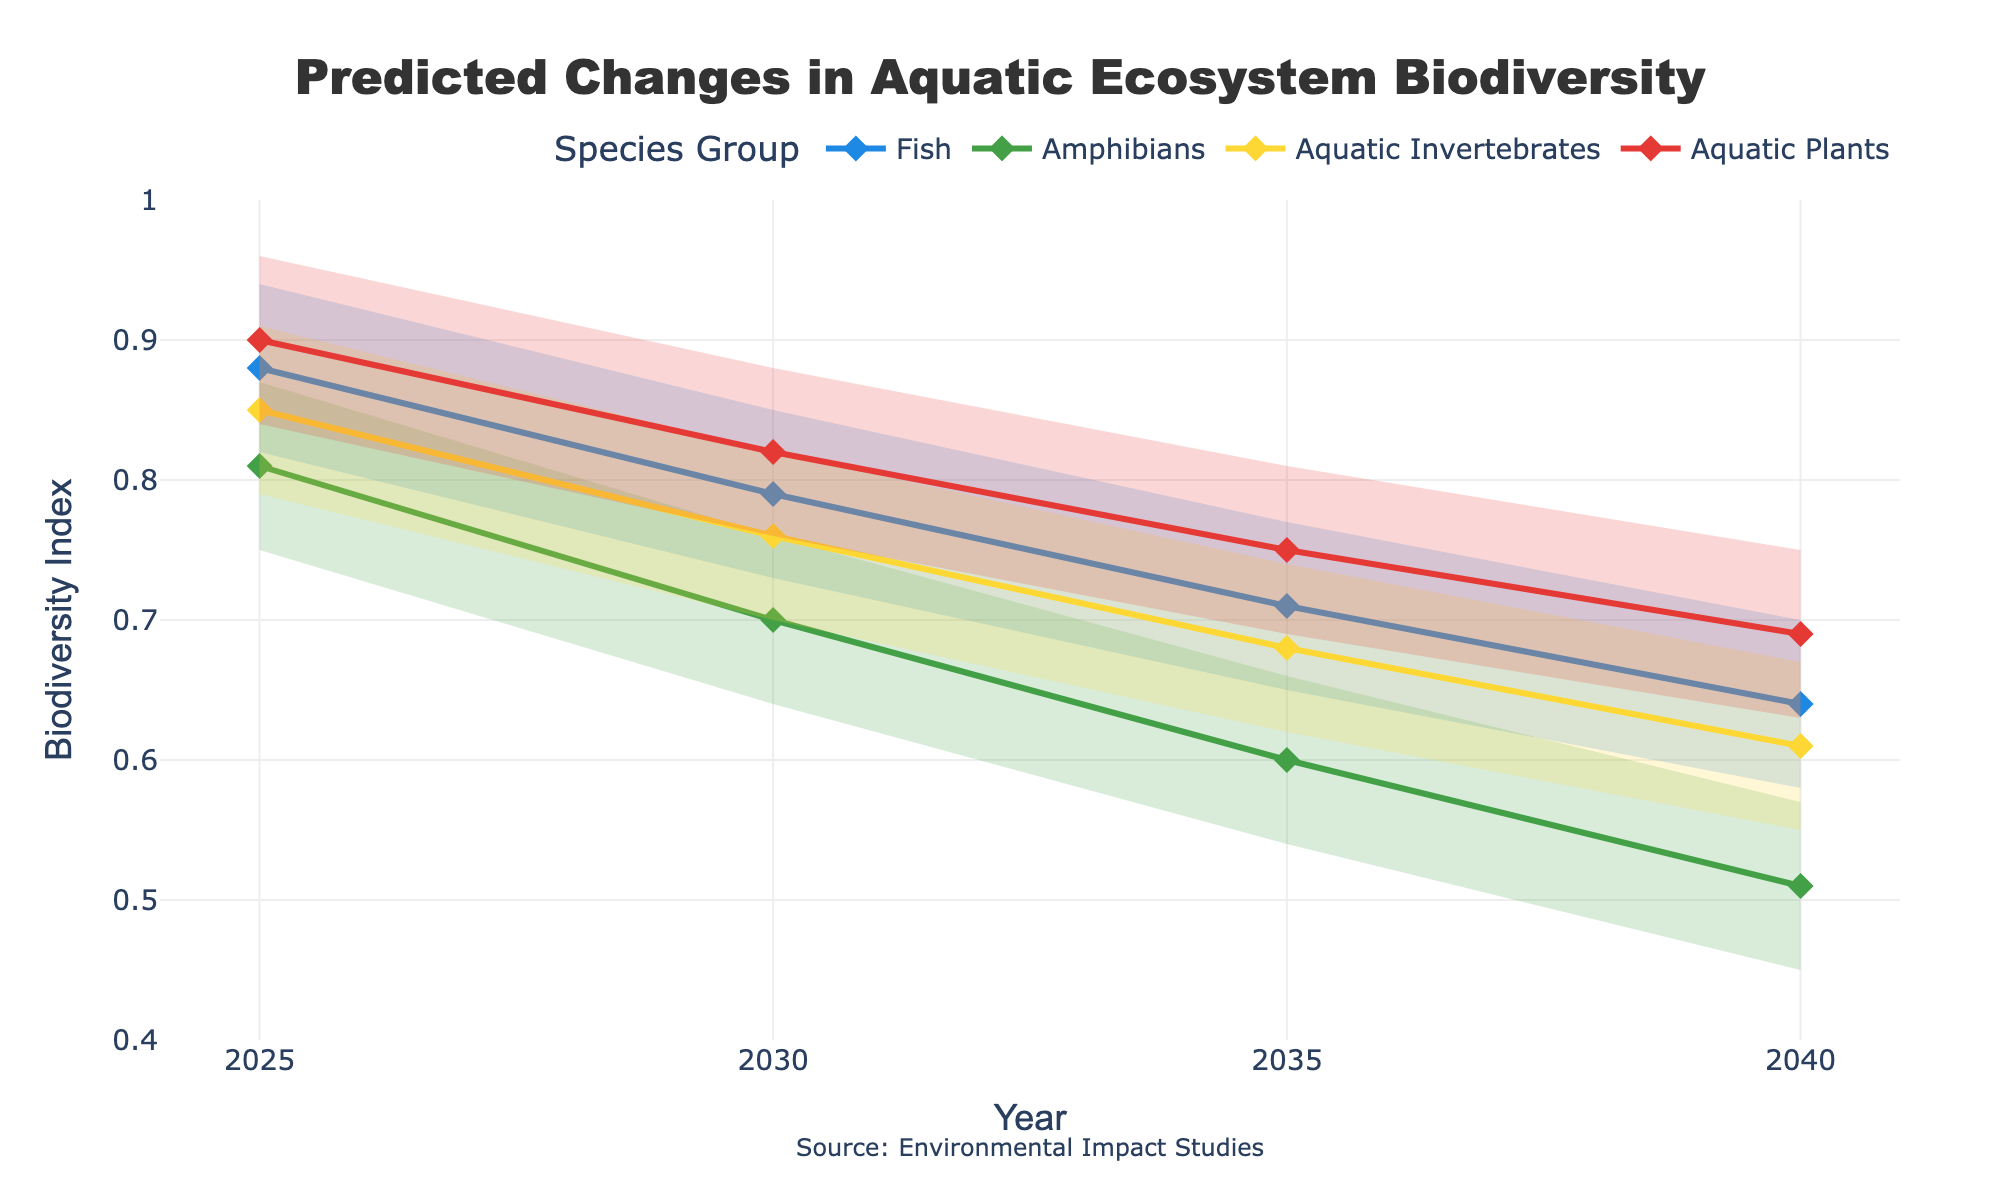What is the title of the chart? The title is located at the top center of the chart, providing an overview of the data being presented.
Answer: Predicted Changes in Aquatic Ecosystem Biodiversity What is the Y-axis title? The Y-axis title is displayed vertically along the Y-axis on the left side of the chart, indicating what the values on this axis represent.
Answer: Biodiversity Index What species group in 2040 has the lowest median value? Look at the median values for all species groups in 2040, which are represented by the diamonds on the lines, and identify the smallest value.
Answer: Amphibians Which year has the highest median value for Fish? Assess the median values for Fish across all years shown on the chart and determine which year has the highest value.
Answer: 2025 How do the median biodiversity indexes for Amphibians change from 2025 to 2040? Observe the median indexes for Amphibians at both 2025 and 2040, and then calculate the difference to understand the change over time.
Answer: They decrease from 0.81 in 2025 to 0.51 in 2040 For which species groups are the confidence intervals the widest in 2025 and 2040, respectively? Compare the widths of the confidence intervals for each species group in both 2025 and 2040, and identify the groups with the widest intervals.
Answer: 2025: Amphibians, 2040: Amphibians Between Fish and Aquatic Plants, which group shows a greater decline in median biodiversity index from 2025 to 2040? Calculate the decline in median biodiversity index for both groups over the period and compare the changes.
Answer: Fish What is the range of the biodiversity index for Aquatic Invertebrates in 2030? Subtract the lower confidence interval value from the upper confidence interval value for Aquatic Invertebrates in 2030.
Answer: 0.12 Which species group shows the least variation in their confidence intervals from 2030 to 2040? Assess the differences in the widths of the confidence intervals for each group over the period and determine which has the least change.
Answer: Aquatic Plants Do any species groups maintain a median biodiversity index above 0.8 throughout the years displayed? Inspect the medians for each species group across all displayed years to see if any remain above 0.8.
Answer: No 